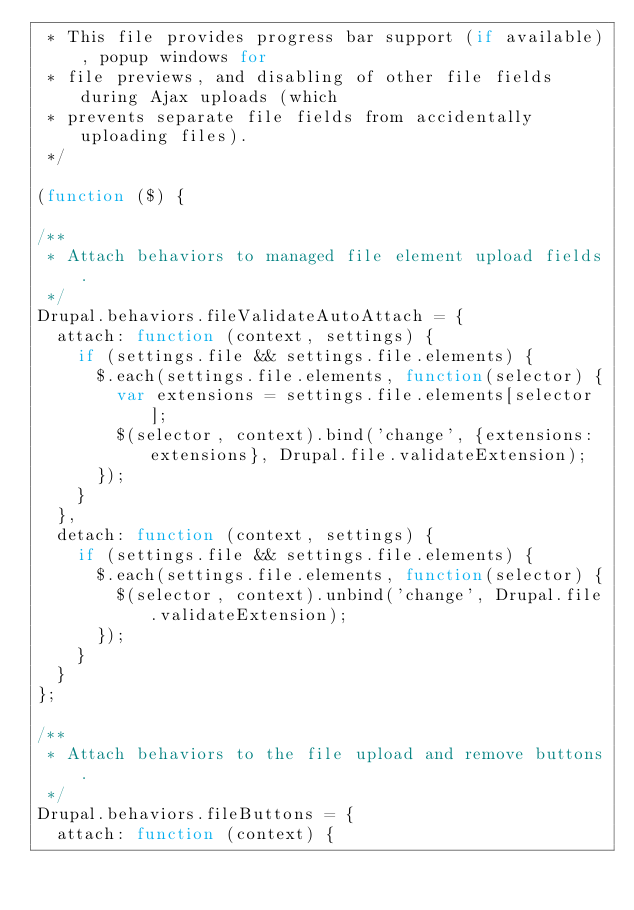Convert code to text. <code><loc_0><loc_0><loc_500><loc_500><_JavaScript_> * This file provides progress bar support (if available), popup windows for
 * file previews, and disabling of other file fields during Ajax uploads (which
 * prevents separate file fields from accidentally uploading files).
 */

(function ($) {

/**
 * Attach behaviors to managed file element upload fields.
 */
Drupal.behaviors.fileValidateAutoAttach = {
  attach: function (context, settings) {
    if (settings.file && settings.file.elements) {
      $.each(settings.file.elements, function(selector) {
        var extensions = settings.file.elements[selector];
        $(selector, context).bind('change', {extensions: extensions}, Drupal.file.validateExtension);
      });
    }
  },
  detach: function (context, settings) {
    if (settings.file && settings.file.elements) {
      $.each(settings.file.elements, function(selector) {
        $(selector, context).unbind('change', Drupal.file.validateExtension);
      });
    }
  }
};

/**
 * Attach behaviors to the file upload and remove buttons.
 */
Drupal.behaviors.fileButtons = {
  attach: function (context) {</code> 